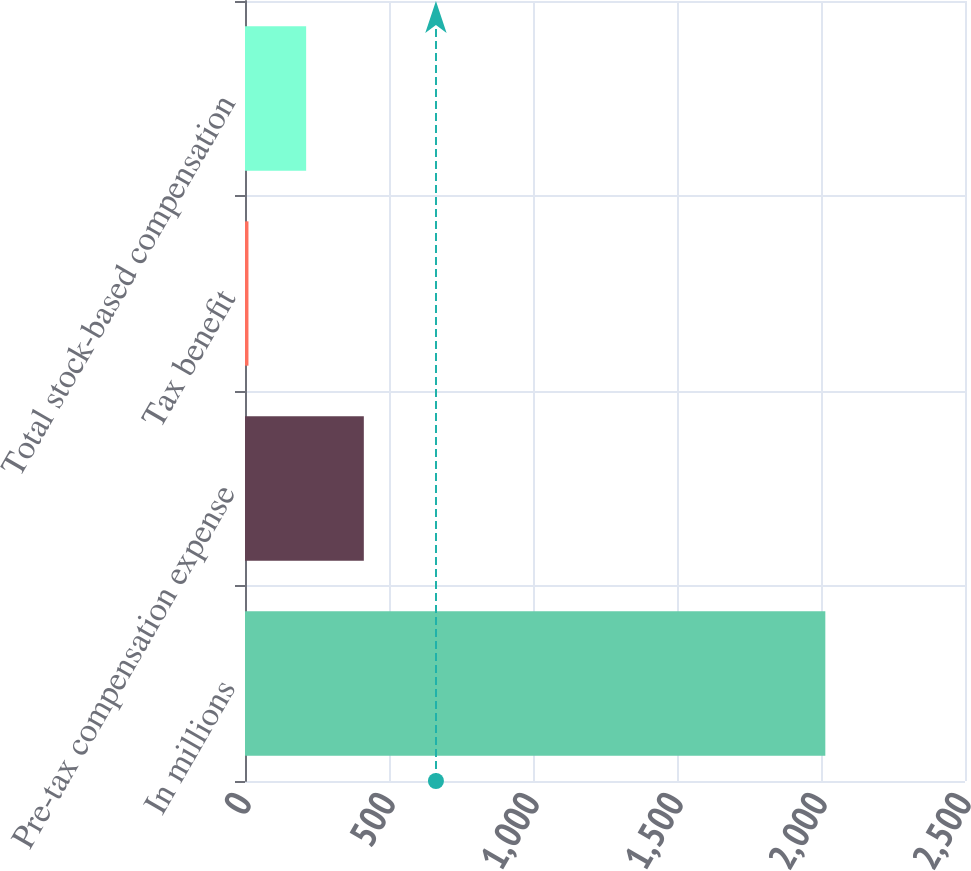<chart> <loc_0><loc_0><loc_500><loc_500><bar_chart><fcel>In millions<fcel>Pre-tax compensation expense<fcel>Tax benefit<fcel>Total stock-based compensation<nl><fcel>2015<fcel>412.6<fcel>12<fcel>212.3<nl></chart> 